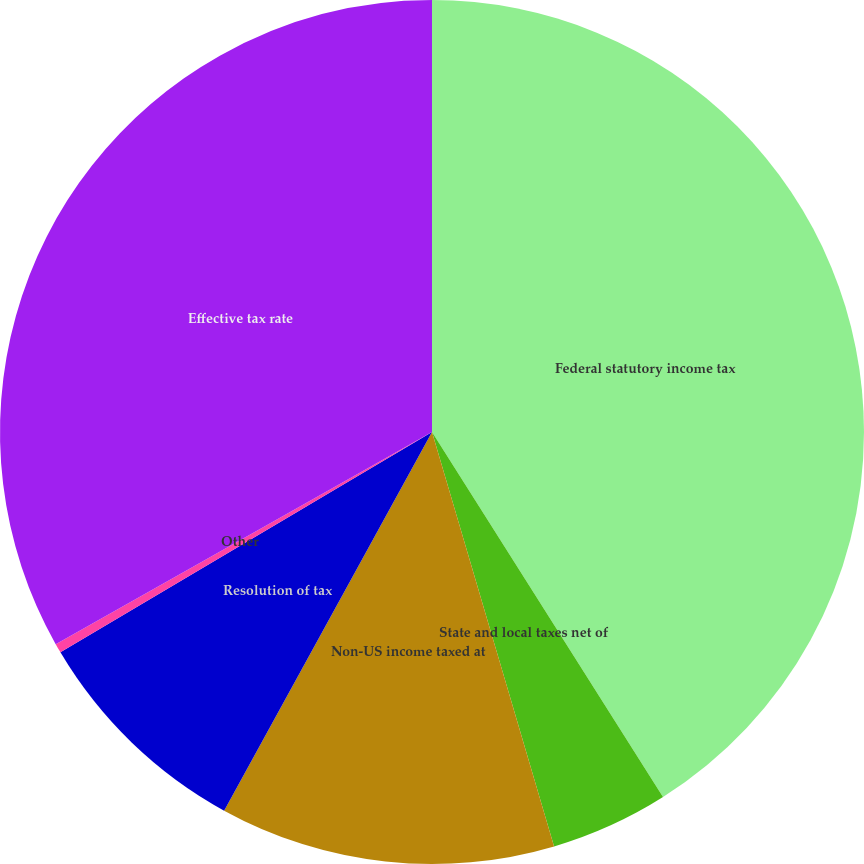<chart> <loc_0><loc_0><loc_500><loc_500><pie_chart><fcel>Federal statutory income tax<fcel>State and local taxes net of<fcel>Non-US income taxed at<fcel>Resolution of tax<fcel>Other<fcel>Effective tax rate<nl><fcel>41.02%<fcel>4.42%<fcel>12.55%<fcel>8.49%<fcel>0.35%<fcel>33.17%<nl></chart> 